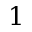Convert formula to latex. <formula><loc_0><loc_0><loc_500><loc_500>1</formula> 